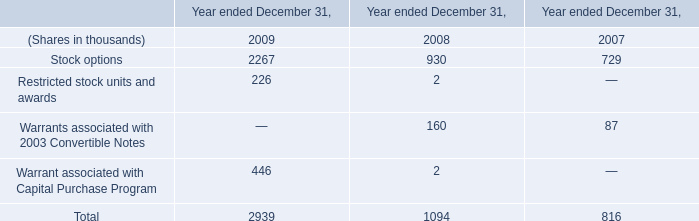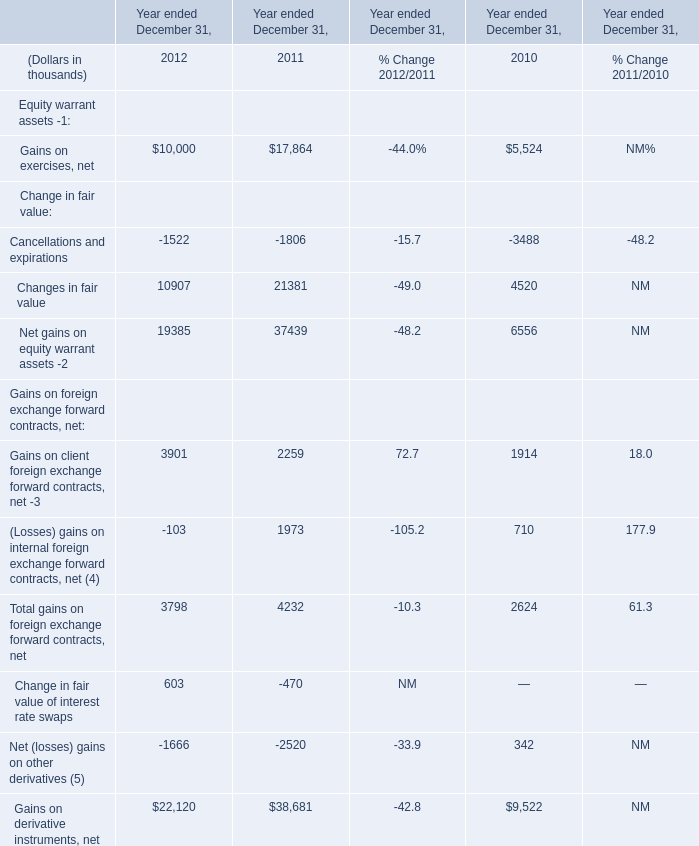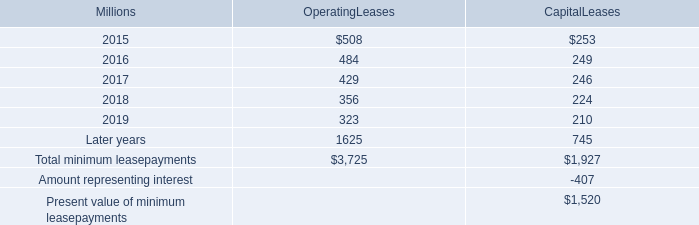What is the average value of Gains on exercises, net in 2012 and Stock options in 2009 ? (in thousand) 
Computations: ((10000 + 2267) / 2)
Answer: 6133.5. Does Changes in fair value keeps increasing each year between 2011 and 2012? 
Answer: NO. What is the total amount of Gains on exercises, net of Year ended December 31, 2010, and Stock options of Year ended December 31, 2009 ? 
Computations: (5524.0 + 2267.0)
Answer: 7791.0. 